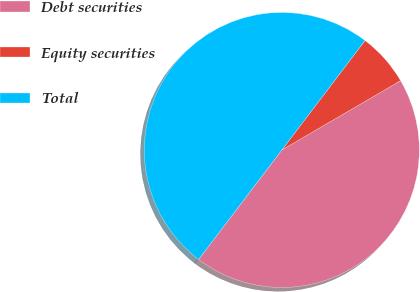<chart> <loc_0><loc_0><loc_500><loc_500><pie_chart><fcel>Debt securities<fcel>Equity securities<fcel>Total<nl><fcel>43.75%<fcel>6.25%<fcel>50.0%<nl></chart> 